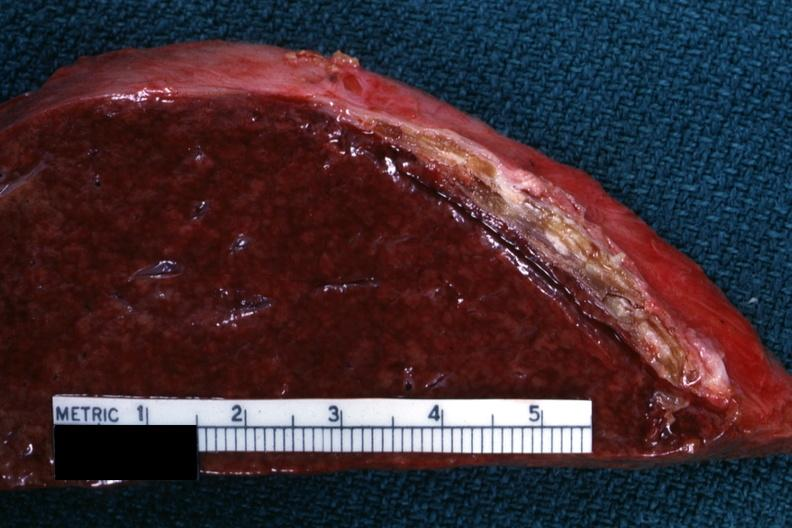s endometritis postpartum present?
Answer the question using a single word or phrase. No 